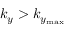<formula> <loc_0><loc_0><loc_500><loc_500>k _ { y } > k _ { y _ { \max } }</formula> 